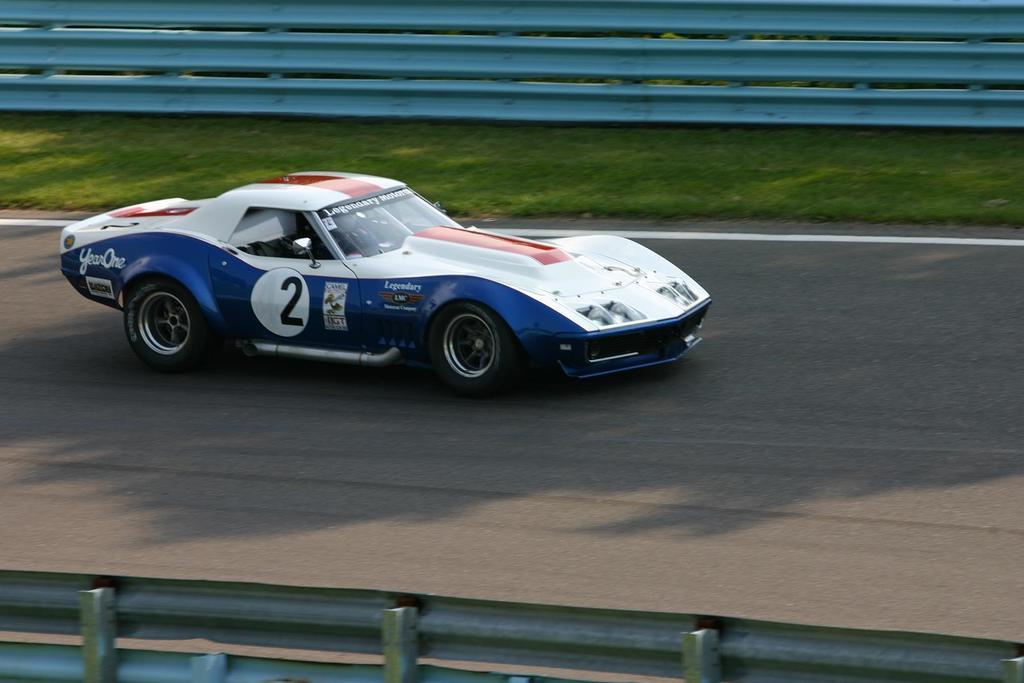Could you give a brief overview of what you see in this image? This is the picture of a place where we have a car on the road and to the side there is some grass and fencing. 